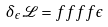Convert formula to latex. <formula><loc_0><loc_0><loc_500><loc_500>\delta _ { \epsilon } { \mathcal { L } } = f f f f \epsilon</formula> 